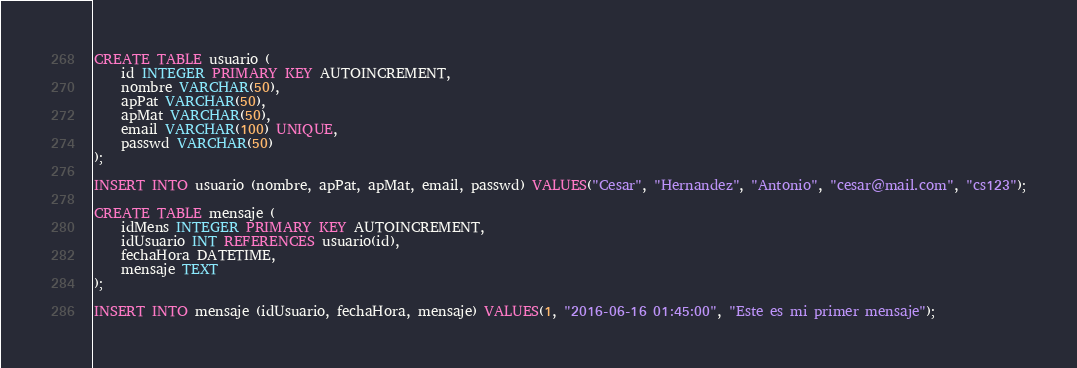<code> <loc_0><loc_0><loc_500><loc_500><_SQL_>CREATE TABLE usuario (
	id INTEGER PRIMARY KEY AUTOINCREMENT,
	nombre VARCHAR(50),
	apPat VARCHAR(50),
	apMat VARCHAR(50),
	email VARCHAR(100) UNIQUE,
	passwd VARCHAR(50)
);

INSERT INTO usuario (nombre, apPat, apMat, email, passwd) VALUES("Cesar", "Hernandez", "Antonio", "cesar@mail.com", "cs123");

CREATE TABLE mensaje (
	idMens INTEGER PRIMARY KEY AUTOINCREMENT,
	idUsuario INT REFERENCES usuario(id),
	fechaHora DATETIME,
	mensaje TEXT
);

INSERT INTO mensaje (idUsuario, fechaHora, mensaje) VALUES(1, "2016-06-16 01:45:00", "Este es mi primer mensaje");</code> 